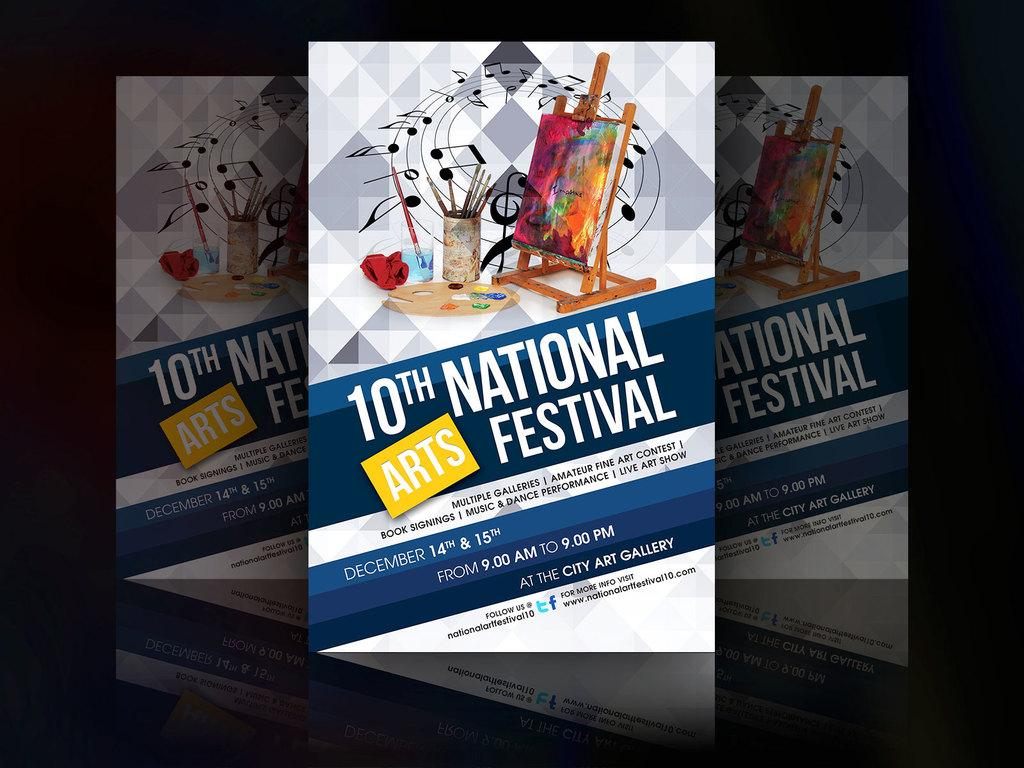Provide a one-sentence caption for the provided image. A banner advertising the 10th National Arts Festival on December 14th and 15th at the City art gallery. 